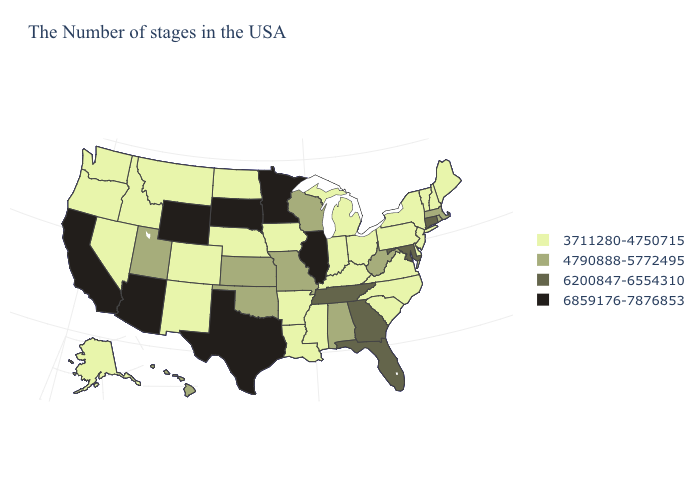Does Montana have the lowest value in the USA?
Concise answer only. Yes. Name the states that have a value in the range 6859176-7876853?
Keep it brief. Illinois, Minnesota, Texas, South Dakota, Wyoming, Arizona, California. Name the states that have a value in the range 6200847-6554310?
Keep it brief. Connecticut, Maryland, Florida, Georgia, Tennessee. Which states have the highest value in the USA?
Keep it brief. Illinois, Minnesota, Texas, South Dakota, Wyoming, Arizona, California. Name the states that have a value in the range 6200847-6554310?
Give a very brief answer. Connecticut, Maryland, Florida, Georgia, Tennessee. What is the lowest value in the USA?
Concise answer only. 3711280-4750715. Does Massachusetts have the lowest value in the Northeast?
Answer briefly. No. What is the highest value in the South ?
Keep it brief. 6859176-7876853. Does Missouri have the lowest value in the MidWest?
Short answer required. No. Among the states that border Oklahoma , which have the lowest value?
Write a very short answer. Arkansas, Colorado, New Mexico. Does Minnesota have the highest value in the USA?
Keep it brief. Yes. Among the states that border Rhode Island , which have the lowest value?
Quick response, please. Massachusetts. Name the states that have a value in the range 3711280-4750715?
Quick response, please. Maine, New Hampshire, Vermont, New York, New Jersey, Delaware, Pennsylvania, Virginia, North Carolina, South Carolina, Ohio, Michigan, Kentucky, Indiana, Mississippi, Louisiana, Arkansas, Iowa, Nebraska, North Dakota, Colorado, New Mexico, Montana, Idaho, Nevada, Washington, Oregon, Alaska. What is the value of Utah?
Write a very short answer. 4790888-5772495. What is the lowest value in the USA?
Short answer required. 3711280-4750715. 